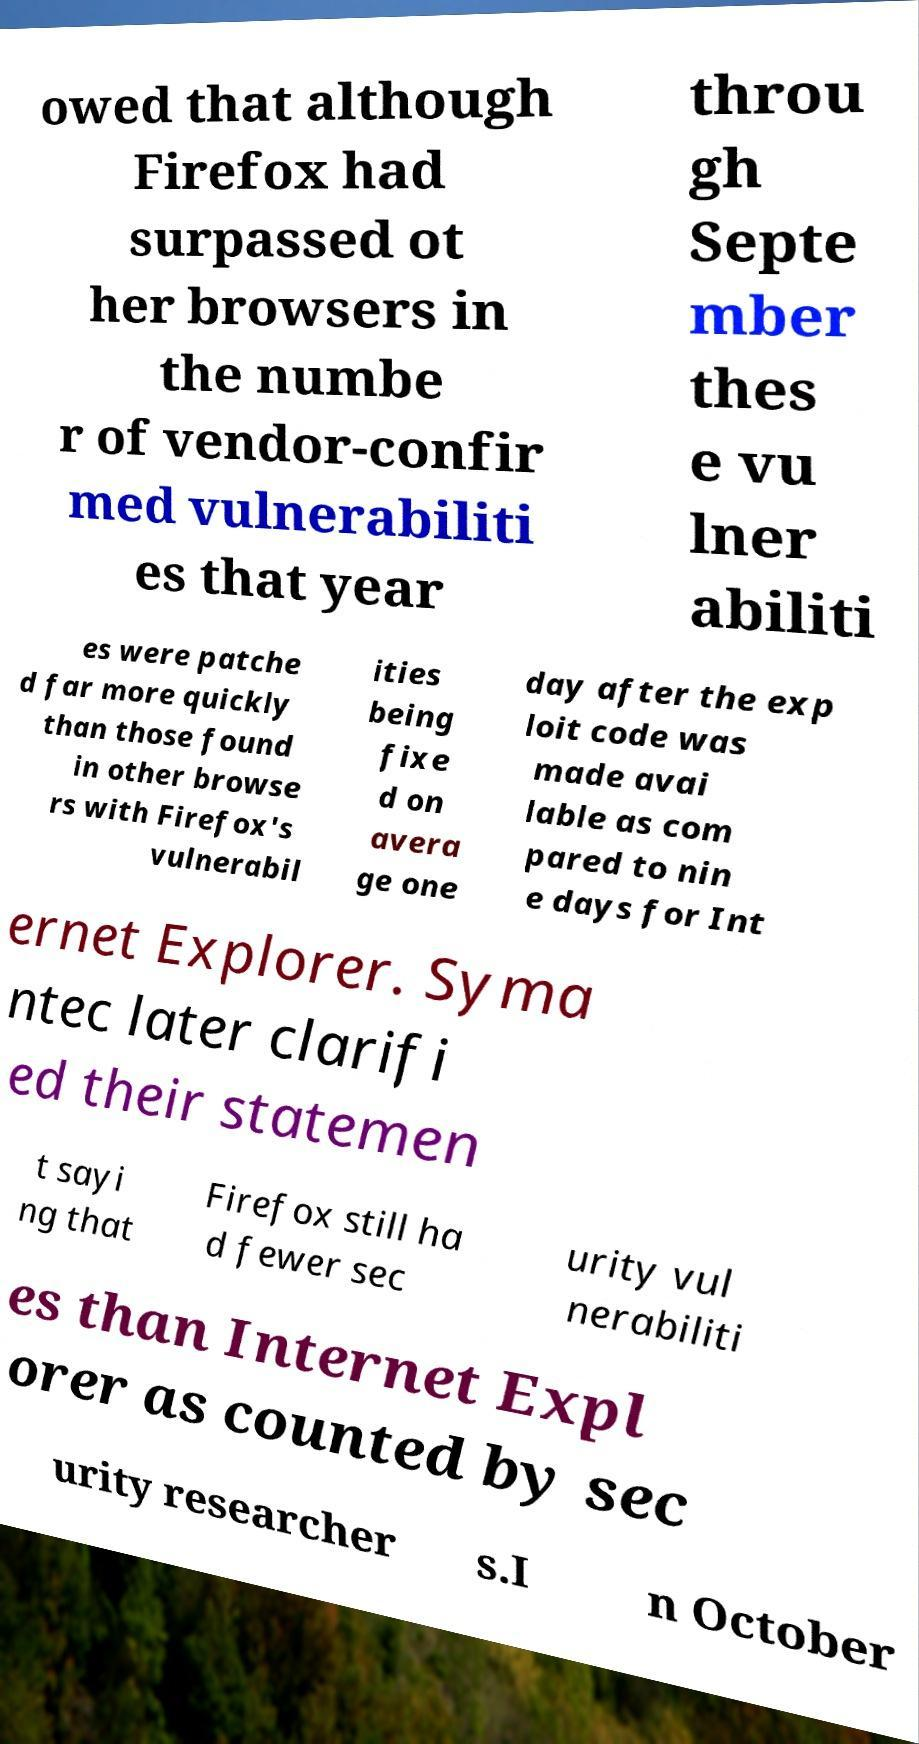Could you assist in decoding the text presented in this image and type it out clearly? owed that although Firefox had surpassed ot her browsers in the numbe r of vendor-confir med vulnerabiliti es that year throu gh Septe mber thes e vu lner abiliti es were patche d far more quickly than those found in other browse rs with Firefox's vulnerabil ities being fixe d on avera ge one day after the exp loit code was made avai lable as com pared to nin e days for Int ernet Explorer. Syma ntec later clarifi ed their statemen t sayi ng that Firefox still ha d fewer sec urity vul nerabiliti es than Internet Expl orer as counted by sec urity researcher s.I n October 